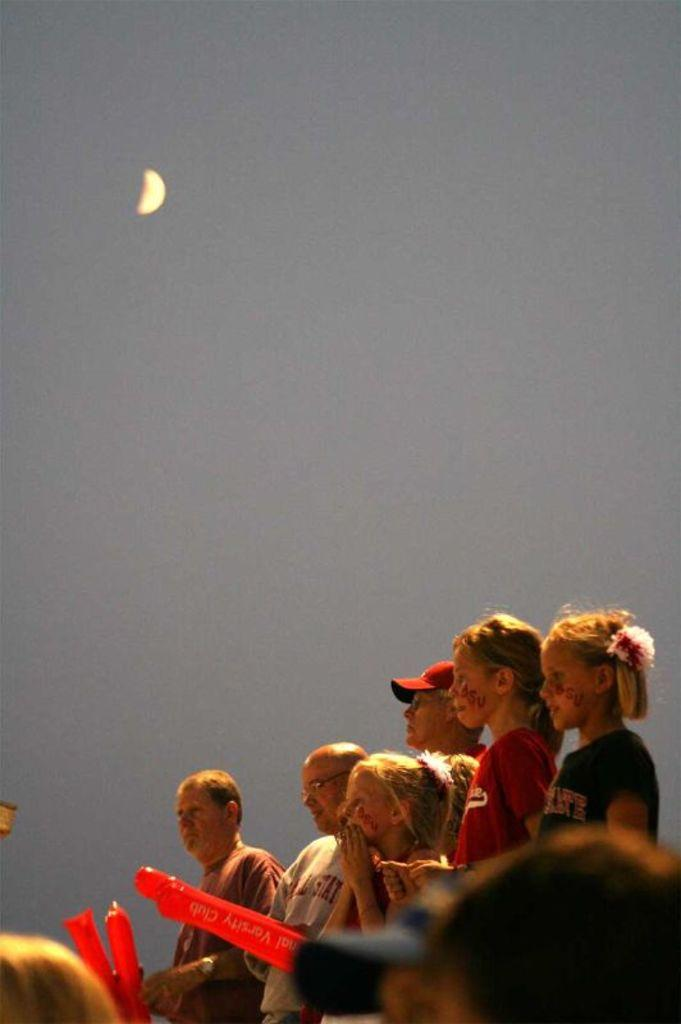Who or what can be seen at the bottom of the image? There are people at the bottom of the image. In which direction are the people facing? The people are facing towards the left side. What are some people holding in the image? Some people are holding red color objects. What celestial body is visible at the top of the image? The moon is visible at the top of the image. Can you see any zippers on the people's clothing in the image? There is no information about zippers or clothing in the provided facts, so it cannot be determined from the image. 